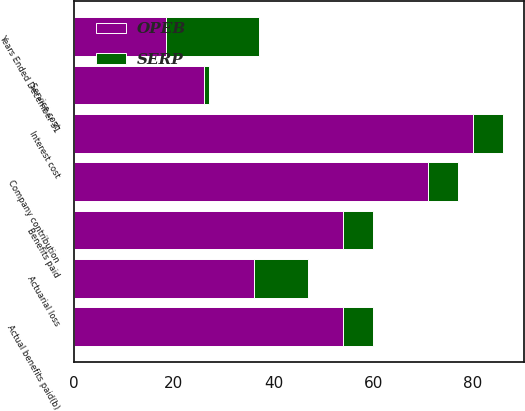Convert chart to OTSL. <chart><loc_0><loc_0><loc_500><loc_500><stacked_bar_chart><ecel><fcel>Years Ended December 31<fcel>Service cost<fcel>Interest cost<fcel>Actuarial loss<fcel>Benefits paid<fcel>Company contribution<fcel>Actual benefits paid(b)<nl><fcel>SERP<fcel>18.5<fcel>1<fcel>6<fcel>11<fcel>6<fcel>6<fcel>6<nl><fcel>OPEB<fcel>18.5<fcel>26<fcel>80<fcel>36<fcel>54<fcel>71<fcel>54<nl></chart> 